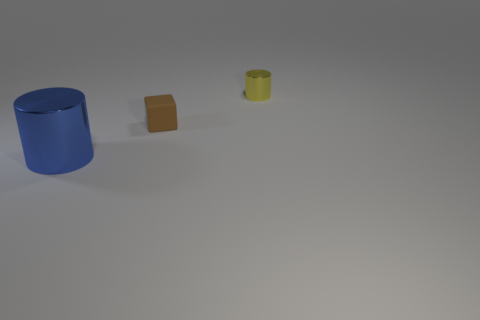Add 3 blue metallic objects. How many objects exist? 6 Subtract all cylinders. How many objects are left? 1 Add 2 blue cylinders. How many blue cylinders are left? 3 Add 1 brown blocks. How many brown blocks exist? 2 Subtract 1 brown blocks. How many objects are left? 2 Subtract all yellow things. Subtract all brown blocks. How many objects are left? 1 